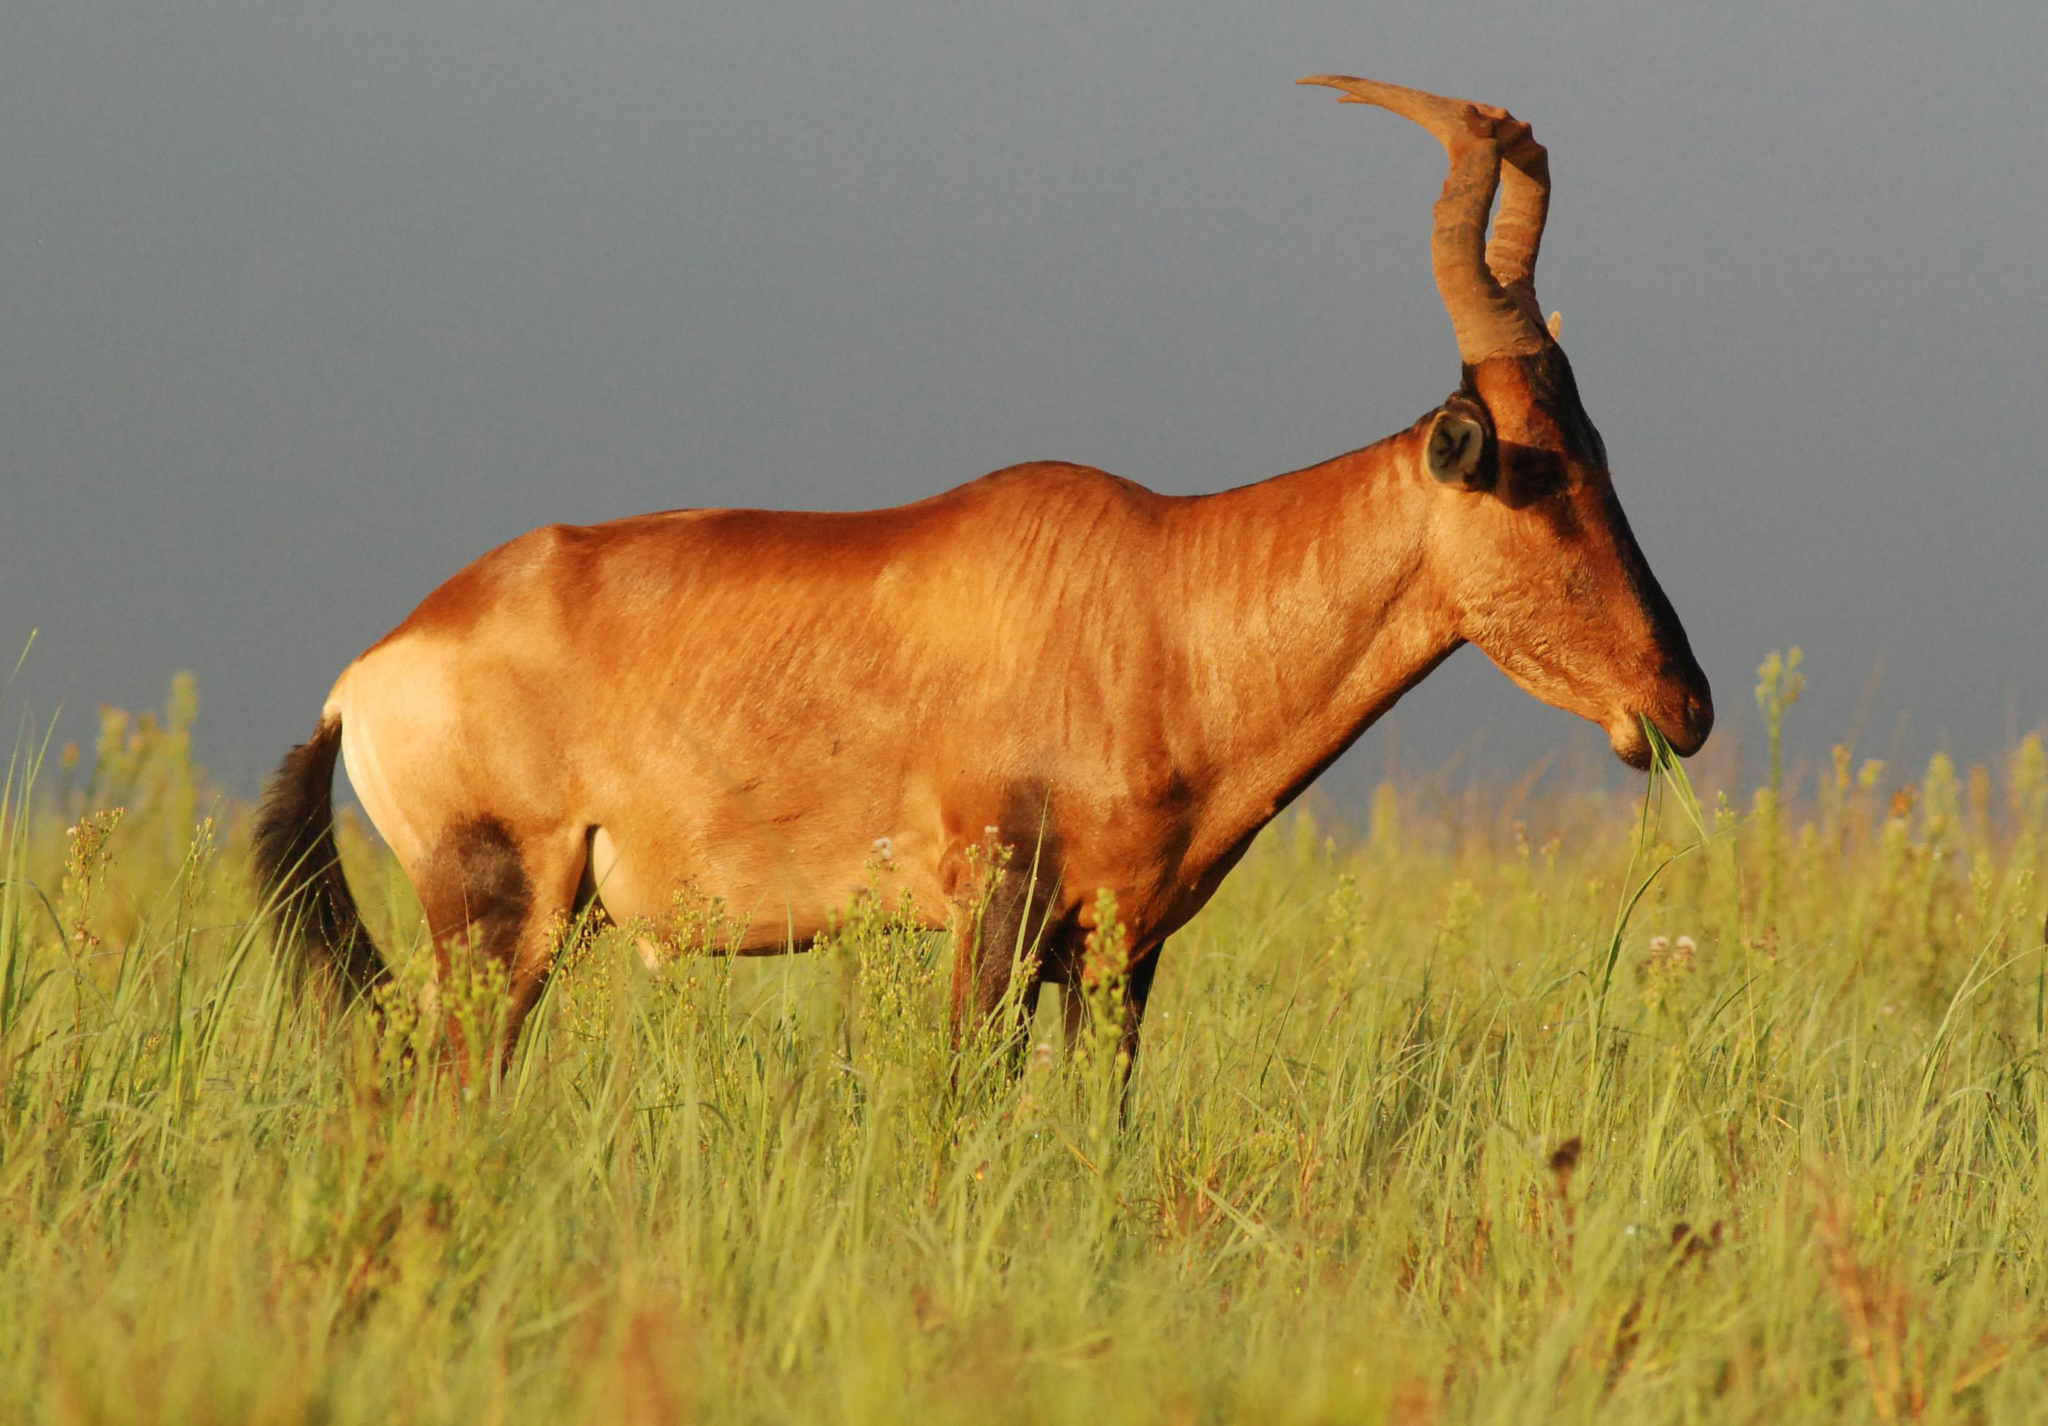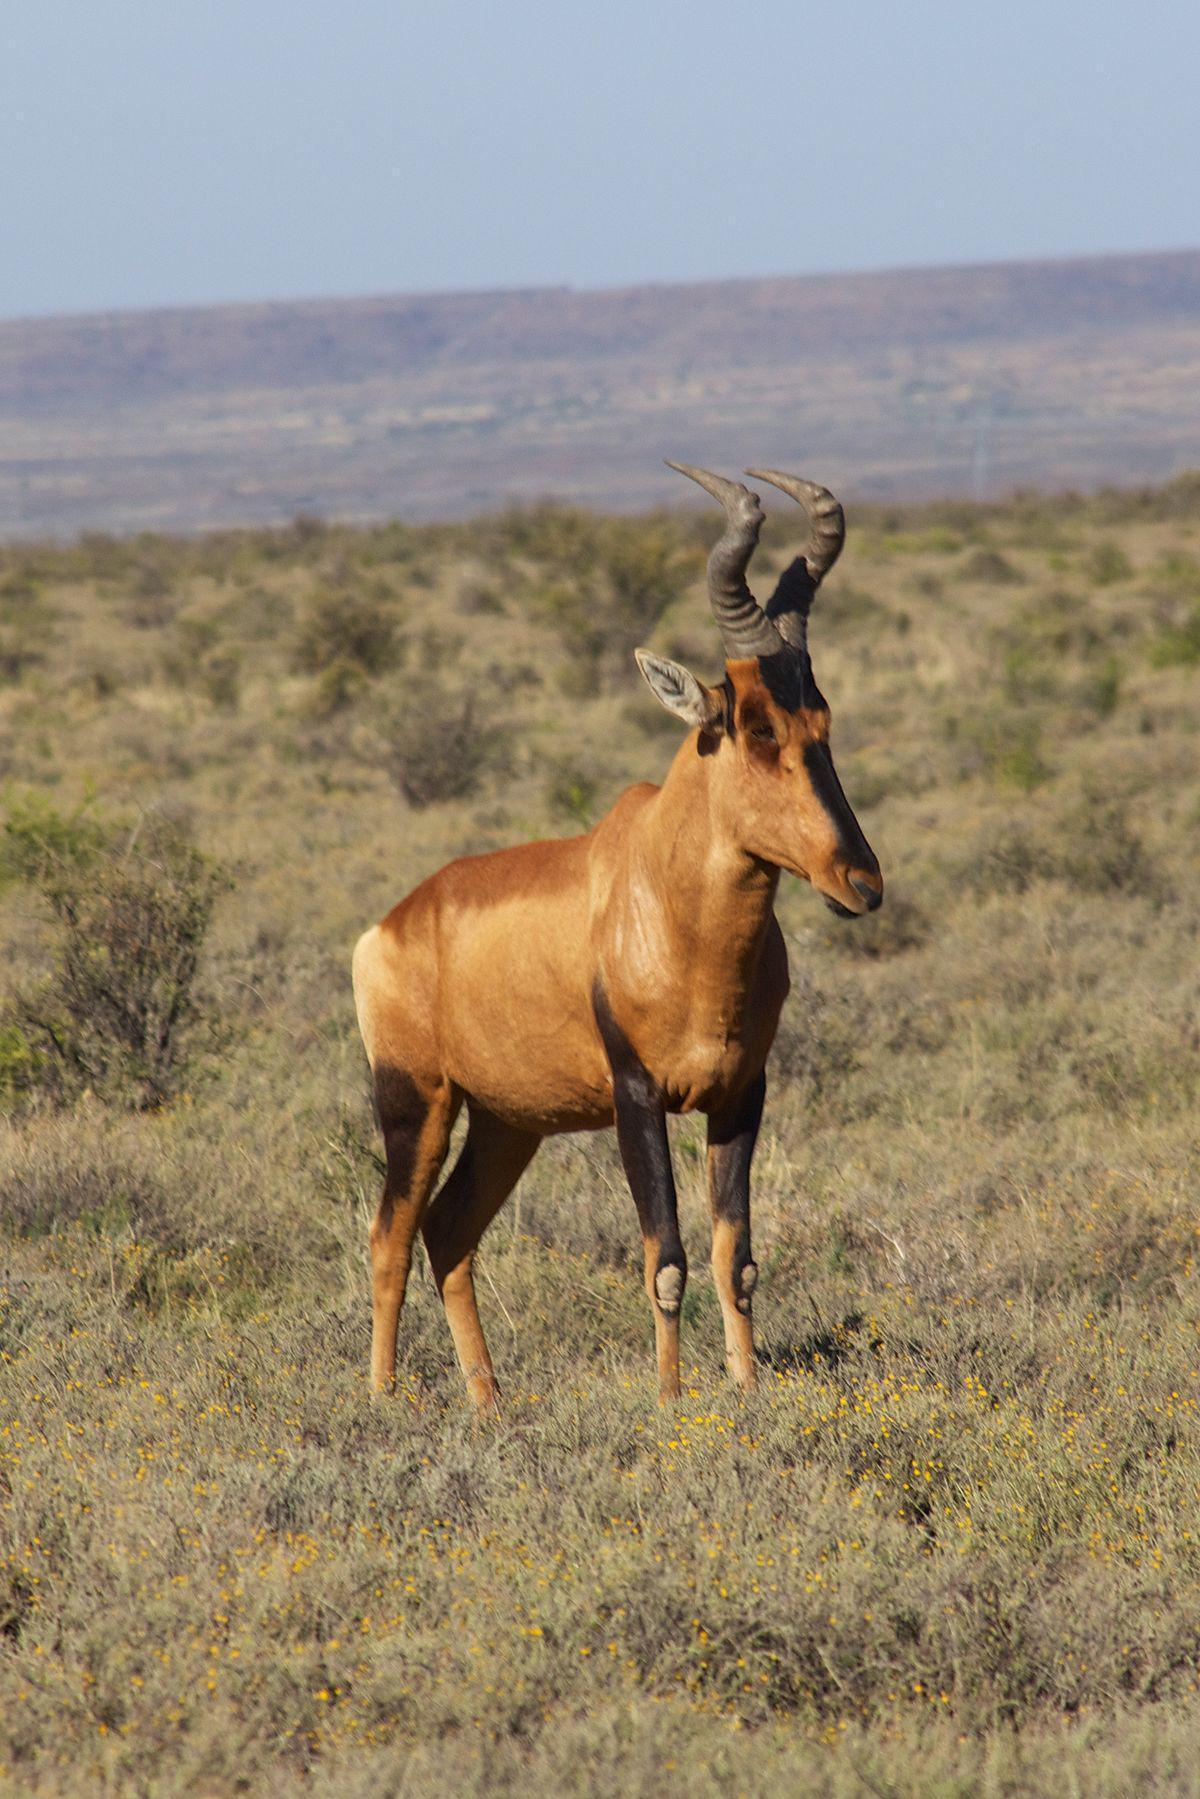The first image is the image on the left, the second image is the image on the right. Considering the images on both sides, is "The animal in the left image is pointed to the right." valid? Answer yes or no. Yes. The first image is the image on the left, the second image is the image on the right. Evaluate the accuracy of this statement regarding the images: "Each image contains only one horned animal, and the animals on the left and right are gazing in the same direction.". Is it true? Answer yes or no. Yes. The first image is the image on the left, the second image is the image on the right. For the images shown, is this caption "All animals are oriented/facing the same direction." true? Answer yes or no. Yes. The first image is the image on the left, the second image is the image on the right. Examine the images to the left and right. Is the description "Each image contains one horned animal, and the animals on the left and right have their bodies turned in the same general direction." accurate? Answer yes or no. Yes. 